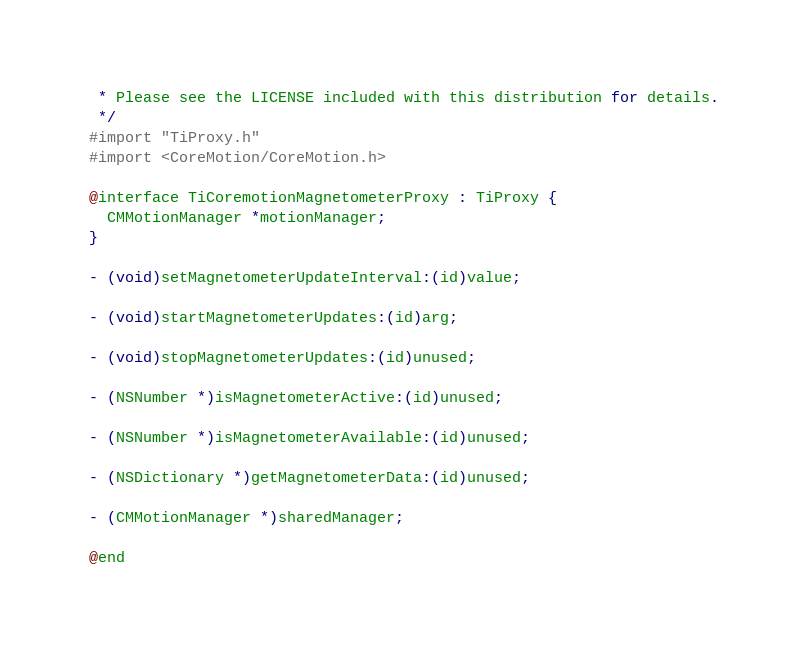<code> <loc_0><loc_0><loc_500><loc_500><_C_> * Please see the LICENSE included with this distribution for details.
 */
#import "TiProxy.h"
#import <CoreMotion/CoreMotion.h>

@interface TiCoremotionMagnetometerProxy : TiProxy {
  CMMotionManager *motionManager;
}

- (void)setMagnetometerUpdateInterval:(id)value;

- (void)startMagnetometerUpdates:(id)arg;

- (void)stopMagnetometerUpdates:(id)unused;

- (NSNumber *)isMagnetometerActive:(id)unused;

- (NSNumber *)isMagnetometerAvailable:(id)unused;

- (NSDictionary *)getMagnetometerData:(id)unused;

- (CMMotionManager *)sharedManager;

@end
</code> 